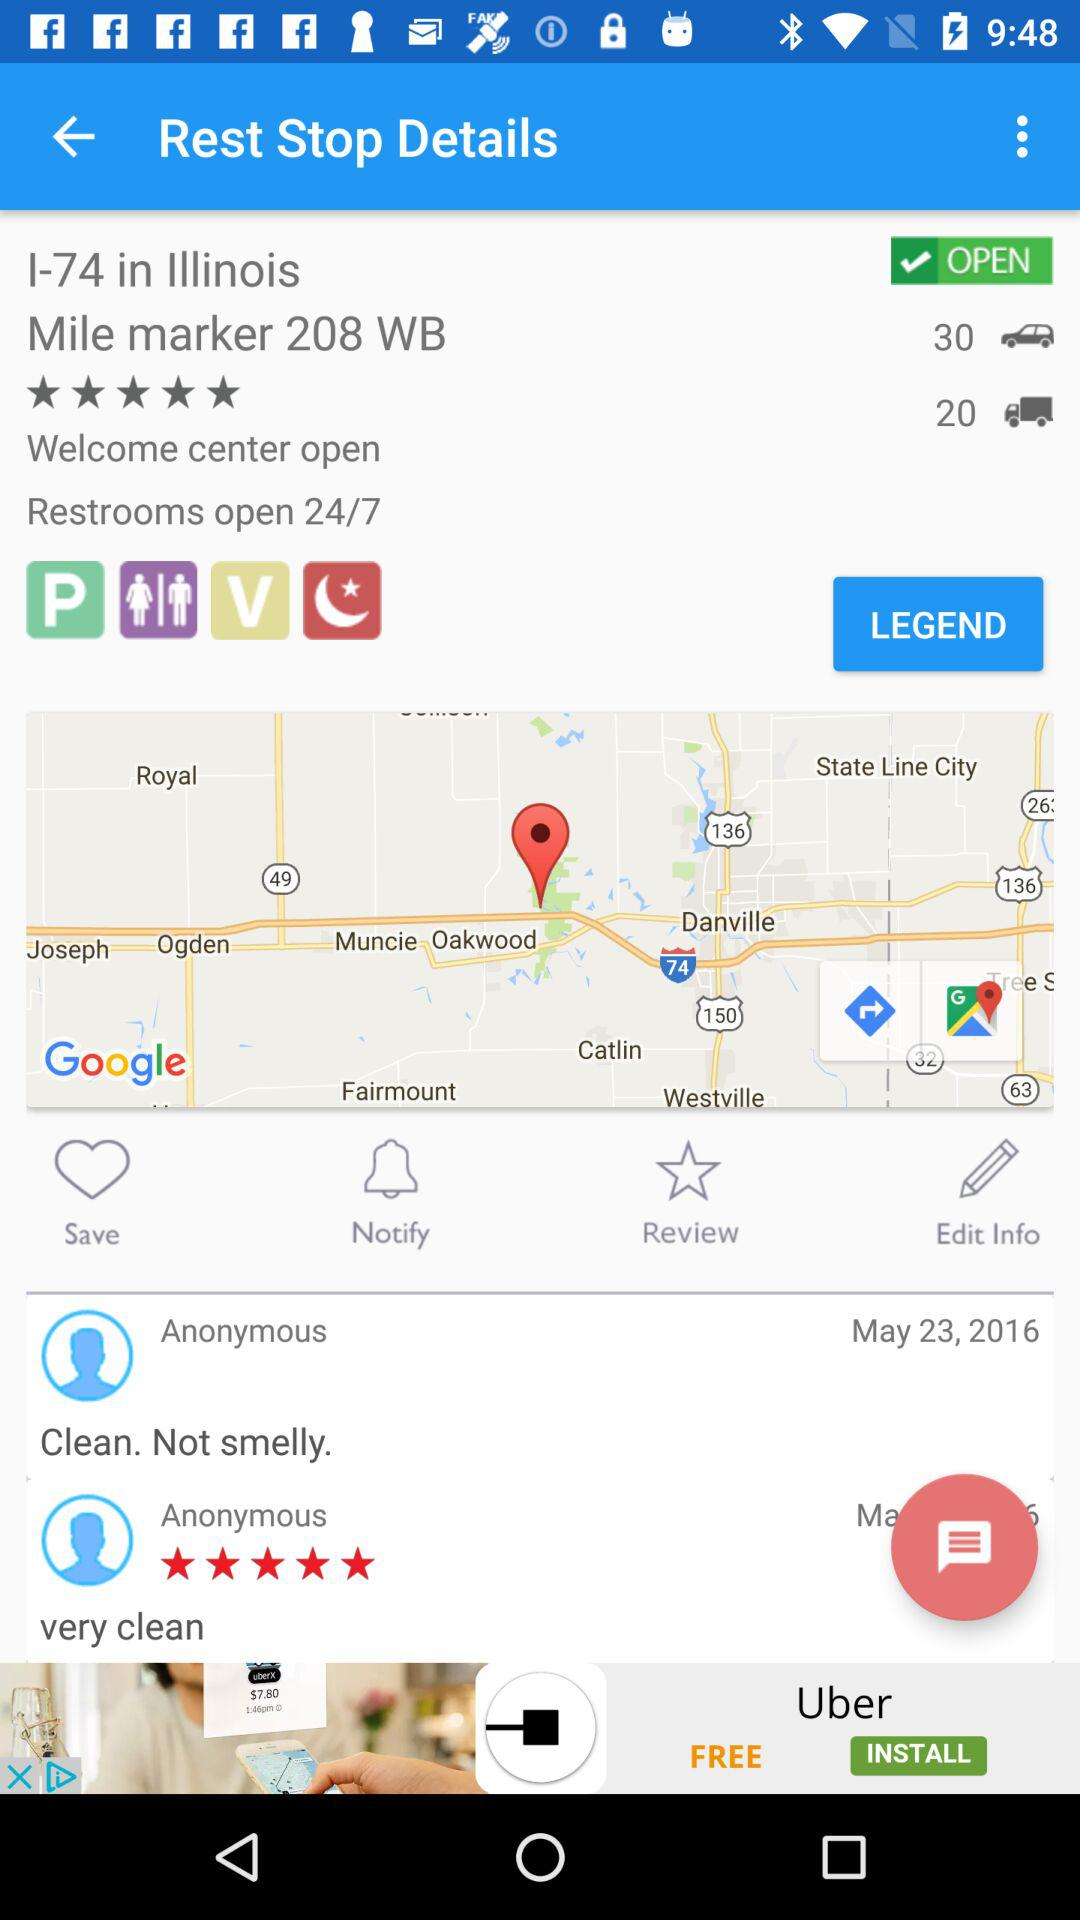What is the address of the rest stop? The address of the rest stop is I-74 in Illinois, mile marker 208 WB. 